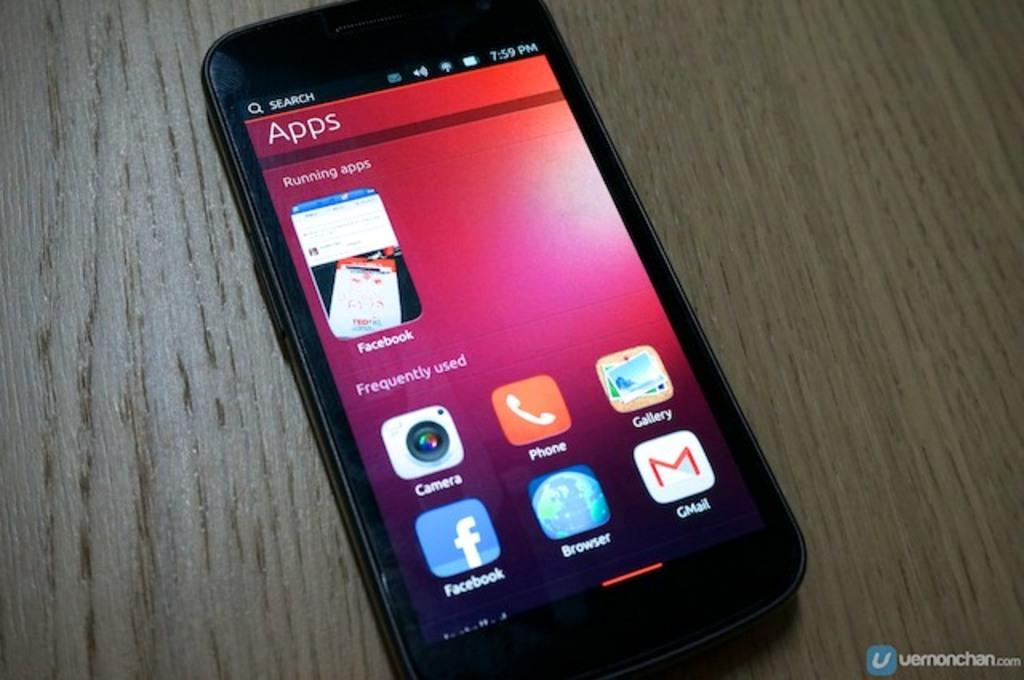<image>
Give a short and clear explanation of the subsequent image. A phone screen displays "running apps" and apps that are "frequently used." 